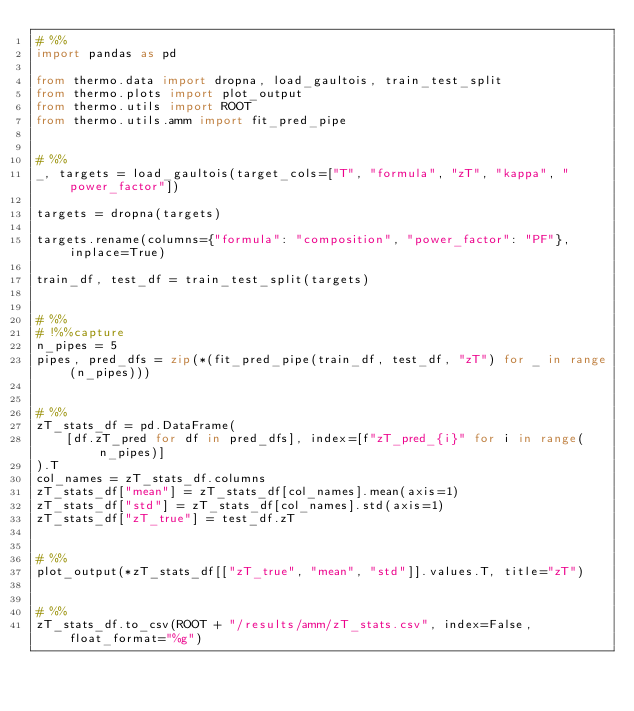<code> <loc_0><loc_0><loc_500><loc_500><_Python_># %%
import pandas as pd

from thermo.data import dropna, load_gaultois, train_test_split
from thermo.plots import plot_output
from thermo.utils import ROOT
from thermo.utils.amm import fit_pred_pipe


# %%
_, targets = load_gaultois(target_cols=["T", "formula", "zT", "kappa", "power_factor"])

targets = dropna(targets)

targets.rename(columns={"formula": "composition", "power_factor": "PF"}, inplace=True)

train_df, test_df = train_test_split(targets)


# %%
# !%%capture
n_pipes = 5
pipes, pred_dfs = zip(*(fit_pred_pipe(train_df, test_df, "zT") for _ in range(n_pipes)))


# %%
zT_stats_df = pd.DataFrame(
    [df.zT_pred for df in pred_dfs], index=[f"zT_pred_{i}" for i in range(n_pipes)]
).T
col_names = zT_stats_df.columns
zT_stats_df["mean"] = zT_stats_df[col_names].mean(axis=1)
zT_stats_df["std"] = zT_stats_df[col_names].std(axis=1)
zT_stats_df["zT_true"] = test_df.zT


# %%
plot_output(*zT_stats_df[["zT_true", "mean", "std"]].values.T, title="zT")


# %%
zT_stats_df.to_csv(ROOT + "/results/amm/zT_stats.csv", index=False, float_format="%g")
</code> 